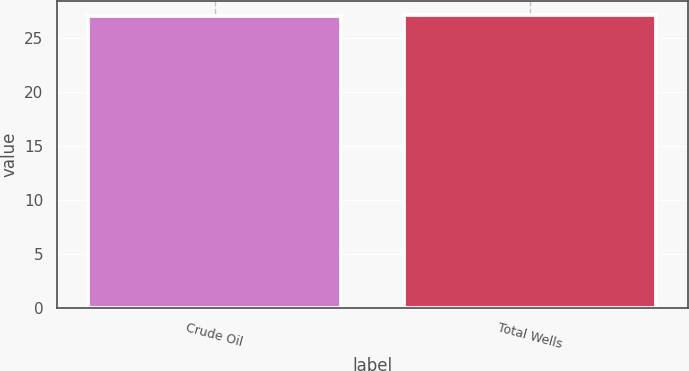Convert chart to OTSL. <chart><loc_0><loc_0><loc_500><loc_500><bar_chart><fcel>Crude Oil<fcel>Total Wells<nl><fcel>27<fcel>27.1<nl></chart> 